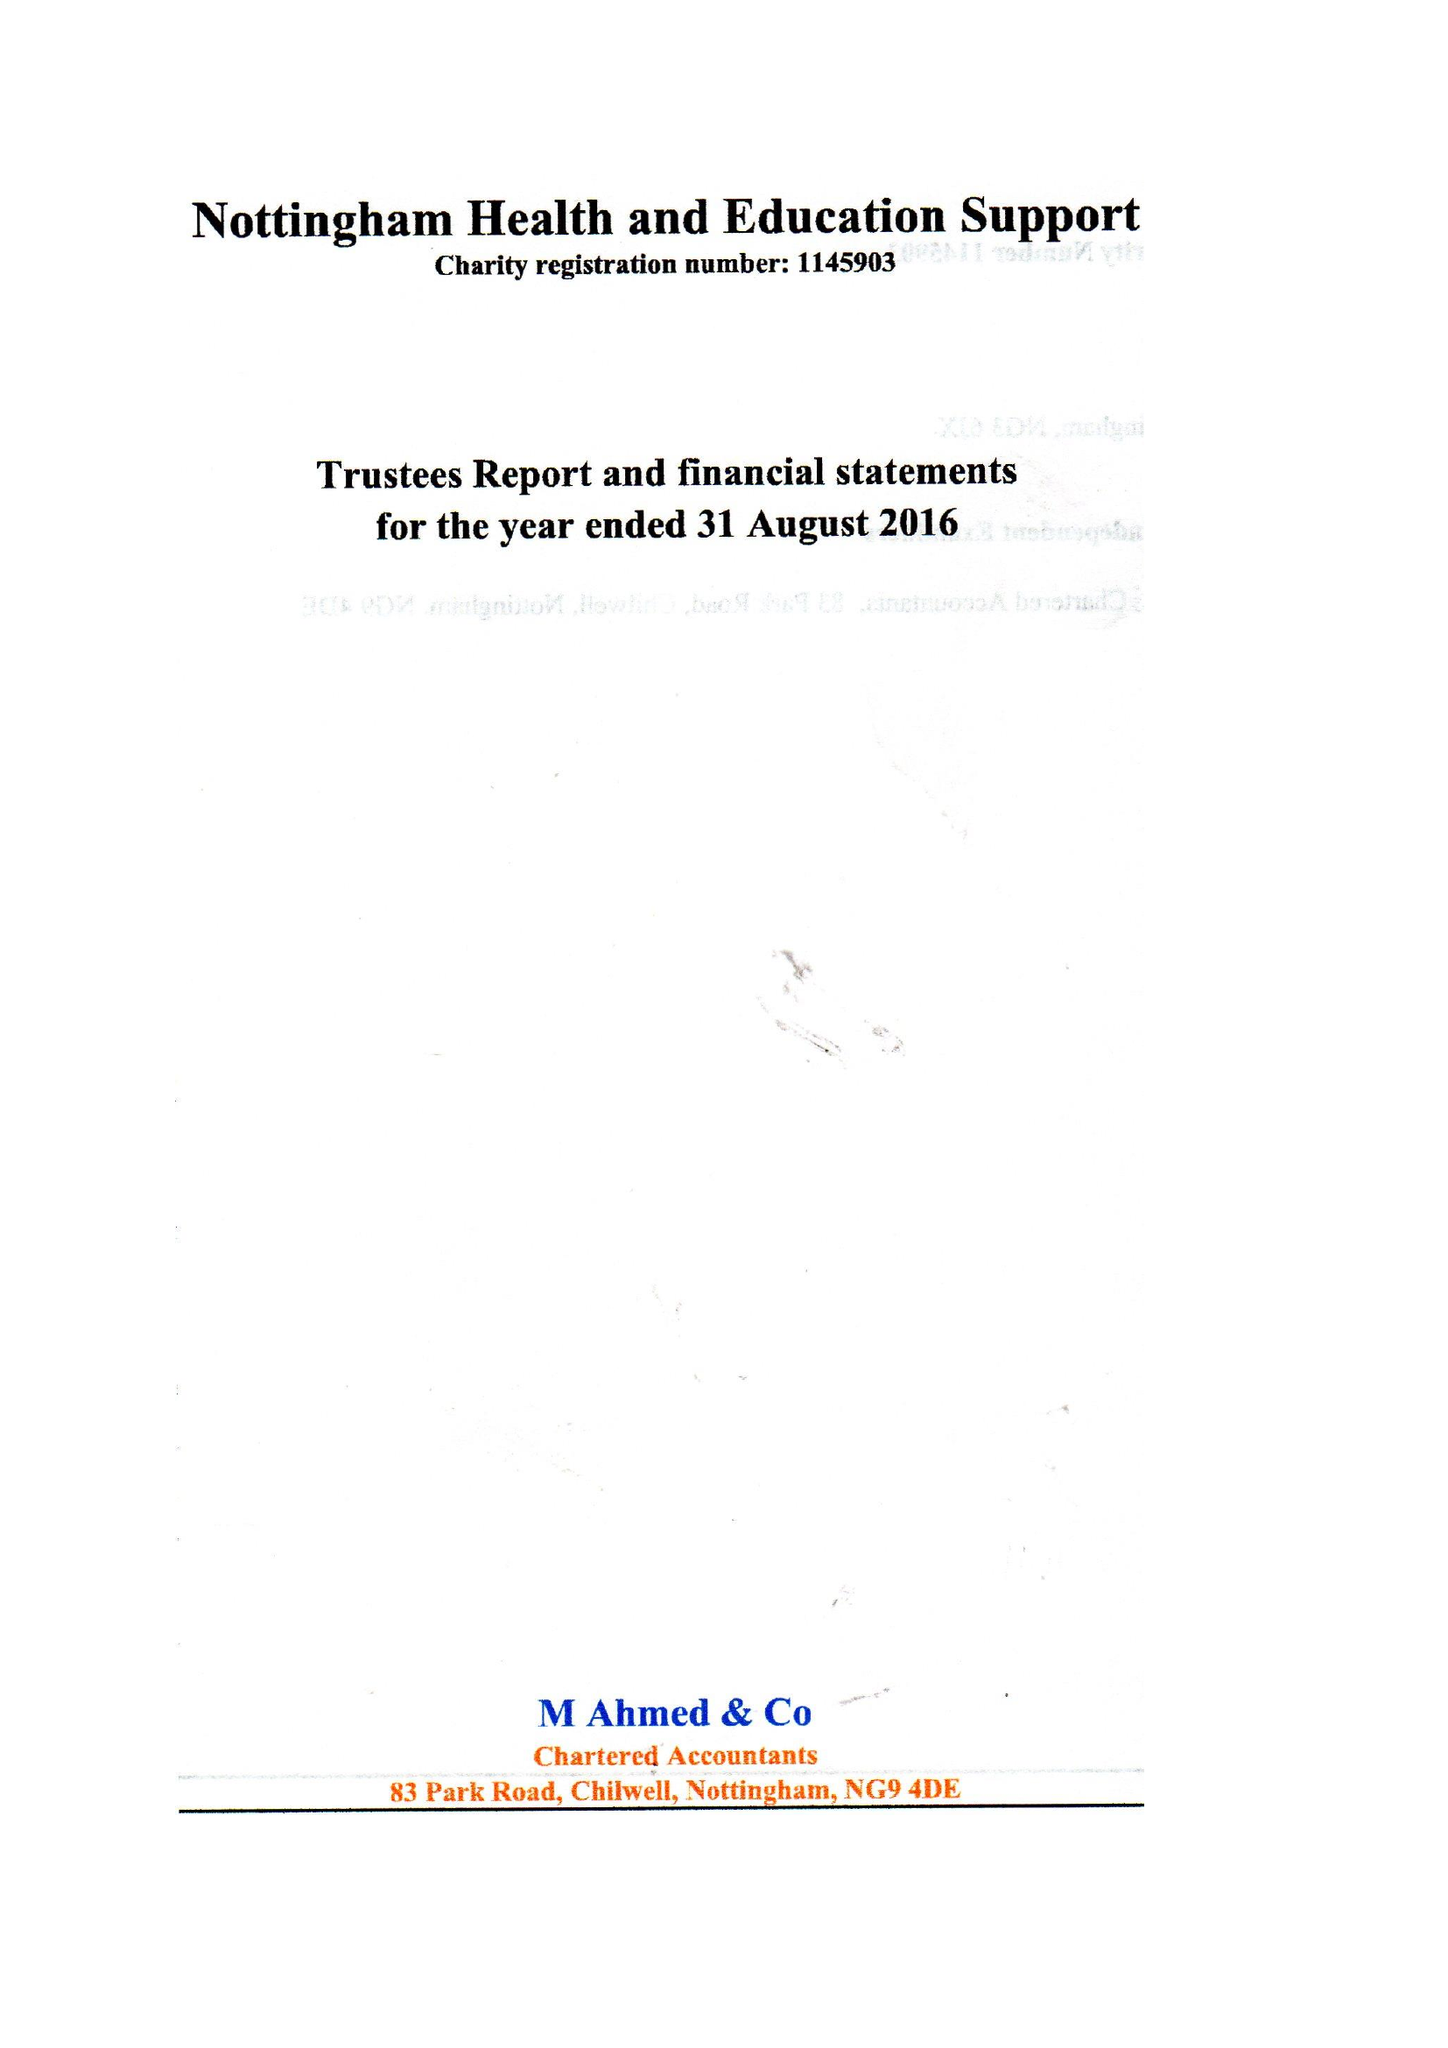What is the value for the income_annually_in_british_pounds?
Answer the question using a single word or phrase. 75009.00 